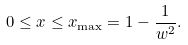<formula> <loc_0><loc_0><loc_500><loc_500>0 \leq x \leq x _ { \max } = 1 - \frac { 1 } { w ^ { 2 } } .</formula> 